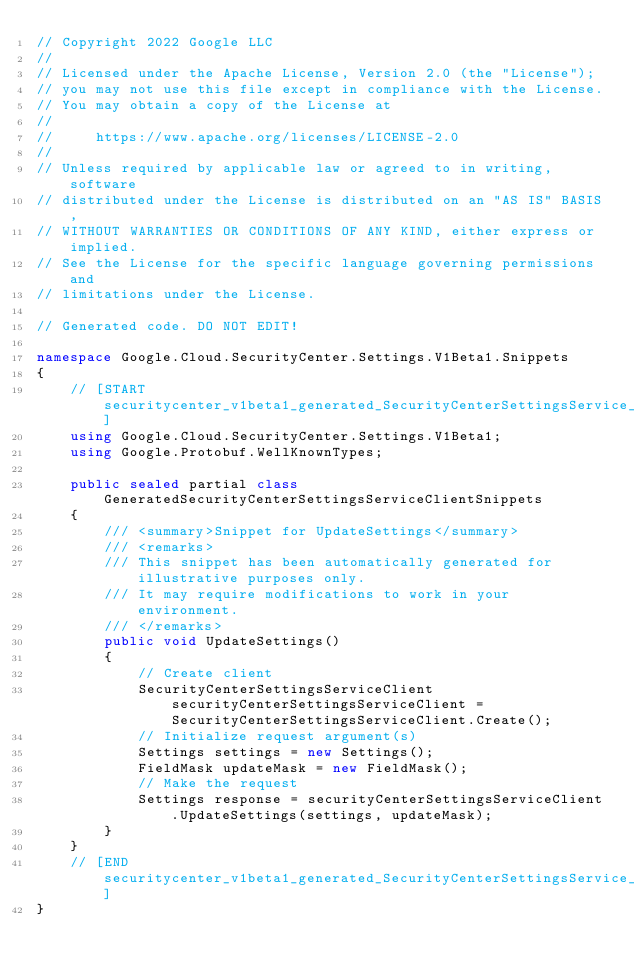<code> <loc_0><loc_0><loc_500><loc_500><_C#_>// Copyright 2022 Google LLC
//
// Licensed under the Apache License, Version 2.0 (the "License");
// you may not use this file except in compliance with the License.
// You may obtain a copy of the License at
//
//     https://www.apache.org/licenses/LICENSE-2.0
//
// Unless required by applicable law or agreed to in writing, software
// distributed under the License is distributed on an "AS IS" BASIS,
// WITHOUT WARRANTIES OR CONDITIONS OF ANY KIND, either express or implied.
// See the License for the specific language governing permissions and
// limitations under the License.

// Generated code. DO NOT EDIT!

namespace Google.Cloud.SecurityCenter.Settings.V1Beta1.Snippets
{
    // [START securitycenter_v1beta1_generated_SecurityCenterSettingsService_UpdateSettings_sync_flattened]
    using Google.Cloud.SecurityCenter.Settings.V1Beta1;
    using Google.Protobuf.WellKnownTypes;

    public sealed partial class GeneratedSecurityCenterSettingsServiceClientSnippets
    {
        /// <summary>Snippet for UpdateSettings</summary>
        /// <remarks>
        /// This snippet has been automatically generated for illustrative purposes only.
        /// It may require modifications to work in your environment.
        /// </remarks>
        public void UpdateSettings()
        {
            // Create client
            SecurityCenterSettingsServiceClient securityCenterSettingsServiceClient = SecurityCenterSettingsServiceClient.Create();
            // Initialize request argument(s)
            Settings settings = new Settings();
            FieldMask updateMask = new FieldMask();
            // Make the request
            Settings response = securityCenterSettingsServiceClient.UpdateSettings(settings, updateMask);
        }
    }
    // [END securitycenter_v1beta1_generated_SecurityCenterSettingsService_UpdateSettings_sync_flattened]
}
</code> 